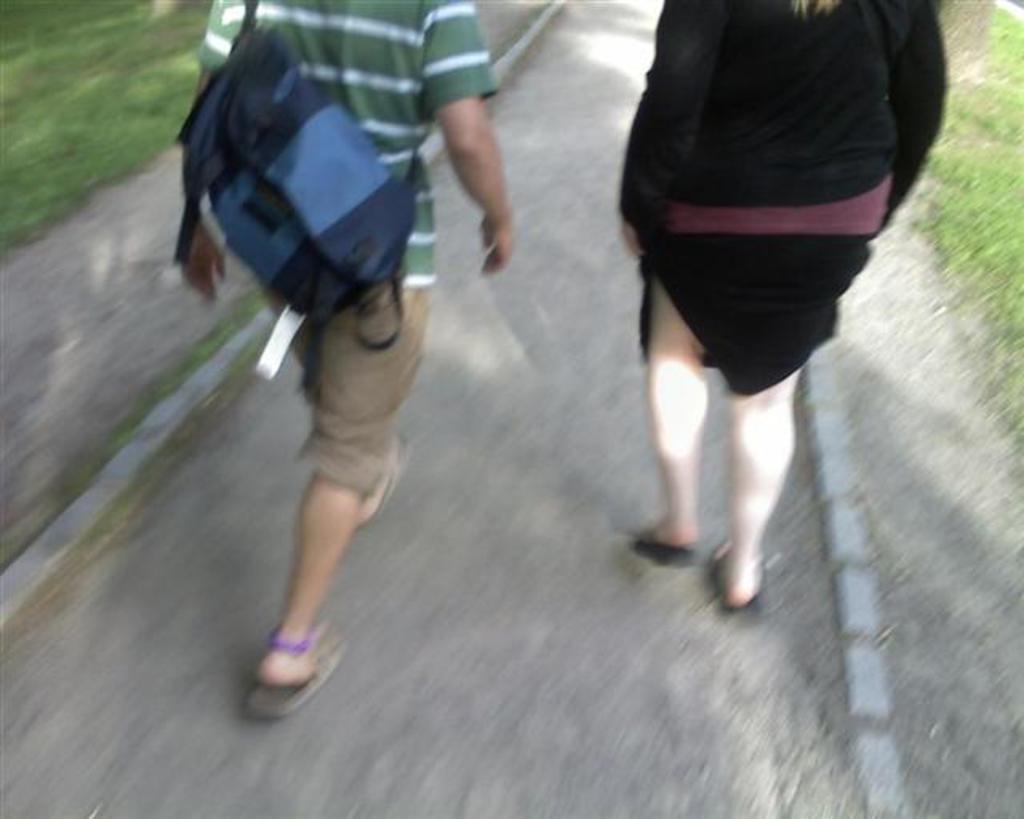Can you describe this image briefly? At the bottom portion of the picture we can see the road and the green grass. In this picture we can see the people walking on the road. We can see a man is wearing the bag. 